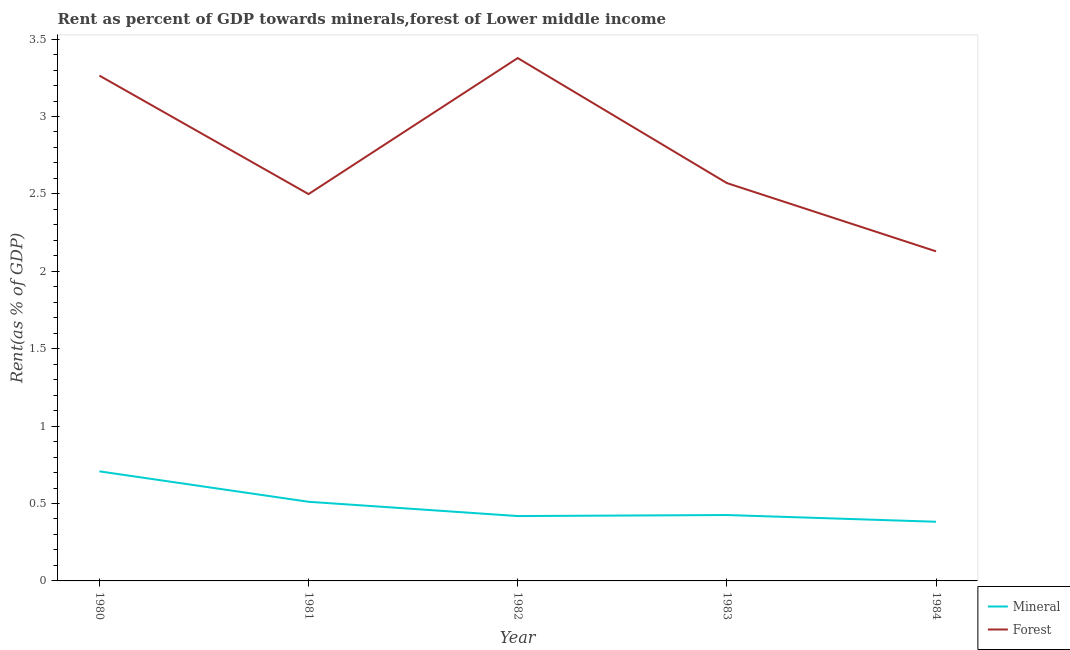Does the line corresponding to forest rent intersect with the line corresponding to mineral rent?
Your response must be concise. No. Is the number of lines equal to the number of legend labels?
Offer a very short reply. Yes. What is the forest rent in 1980?
Provide a short and direct response. 3.26. Across all years, what is the maximum forest rent?
Your answer should be compact. 3.38. Across all years, what is the minimum forest rent?
Your answer should be compact. 2.13. In which year was the mineral rent maximum?
Your answer should be compact. 1980. What is the total mineral rent in the graph?
Ensure brevity in your answer.  2.45. What is the difference between the forest rent in 1982 and that in 1984?
Make the answer very short. 1.25. What is the difference between the forest rent in 1983 and the mineral rent in 1982?
Ensure brevity in your answer.  2.15. What is the average mineral rent per year?
Provide a succinct answer. 0.49. In the year 1982, what is the difference between the mineral rent and forest rent?
Give a very brief answer. -2.96. In how many years, is the mineral rent greater than 2.2 %?
Offer a very short reply. 0. What is the ratio of the mineral rent in 1980 to that in 1982?
Your response must be concise. 1.69. Is the difference between the mineral rent in 1983 and 1984 greater than the difference between the forest rent in 1983 and 1984?
Ensure brevity in your answer.  No. What is the difference between the highest and the second highest forest rent?
Offer a very short reply. 0.11. What is the difference between the highest and the lowest mineral rent?
Your answer should be very brief. 0.33. In how many years, is the forest rent greater than the average forest rent taken over all years?
Offer a terse response. 2. Is the sum of the mineral rent in 1982 and 1984 greater than the maximum forest rent across all years?
Keep it short and to the point. No. Does the mineral rent monotonically increase over the years?
Your answer should be compact. No. Does the graph contain any zero values?
Your response must be concise. No. What is the title of the graph?
Your answer should be very brief. Rent as percent of GDP towards minerals,forest of Lower middle income. Does "From human activities" appear as one of the legend labels in the graph?
Offer a terse response. No. What is the label or title of the Y-axis?
Give a very brief answer. Rent(as % of GDP). What is the Rent(as % of GDP) in Mineral in 1980?
Give a very brief answer. 0.71. What is the Rent(as % of GDP) of Forest in 1980?
Your response must be concise. 3.26. What is the Rent(as % of GDP) of Mineral in 1981?
Give a very brief answer. 0.51. What is the Rent(as % of GDP) of Forest in 1981?
Offer a very short reply. 2.5. What is the Rent(as % of GDP) in Mineral in 1982?
Offer a terse response. 0.42. What is the Rent(as % of GDP) in Forest in 1982?
Keep it short and to the point. 3.38. What is the Rent(as % of GDP) of Mineral in 1983?
Make the answer very short. 0.43. What is the Rent(as % of GDP) of Forest in 1983?
Your answer should be compact. 2.57. What is the Rent(as % of GDP) of Mineral in 1984?
Your answer should be very brief. 0.38. What is the Rent(as % of GDP) in Forest in 1984?
Give a very brief answer. 2.13. Across all years, what is the maximum Rent(as % of GDP) in Mineral?
Give a very brief answer. 0.71. Across all years, what is the maximum Rent(as % of GDP) in Forest?
Ensure brevity in your answer.  3.38. Across all years, what is the minimum Rent(as % of GDP) in Mineral?
Ensure brevity in your answer.  0.38. Across all years, what is the minimum Rent(as % of GDP) in Forest?
Offer a very short reply. 2.13. What is the total Rent(as % of GDP) of Mineral in the graph?
Offer a terse response. 2.45. What is the total Rent(as % of GDP) of Forest in the graph?
Provide a succinct answer. 13.84. What is the difference between the Rent(as % of GDP) in Mineral in 1980 and that in 1981?
Keep it short and to the point. 0.2. What is the difference between the Rent(as % of GDP) of Forest in 1980 and that in 1981?
Provide a short and direct response. 0.77. What is the difference between the Rent(as % of GDP) of Mineral in 1980 and that in 1982?
Keep it short and to the point. 0.29. What is the difference between the Rent(as % of GDP) of Forest in 1980 and that in 1982?
Your answer should be very brief. -0.11. What is the difference between the Rent(as % of GDP) in Mineral in 1980 and that in 1983?
Give a very brief answer. 0.28. What is the difference between the Rent(as % of GDP) in Forest in 1980 and that in 1983?
Offer a terse response. 0.69. What is the difference between the Rent(as % of GDP) of Mineral in 1980 and that in 1984?
Your answer should be very brief. 0.33. What is the difference between the Rent(as % of GDP) in Forest in 1980 and that in 1984?
Offer a terse response. 1.14. What is the difference between the Rent(as % of GDP) of Mineral in 1981 and that in 1982?
Give a very brief answer. 0.09. What is the difference between the Rent(as % of GDP) in Forest in 1981 and that in 1982?
Your answer should be very brief. -0.88. What is the difference between the Rent(as % of GDP) in Mineral in 1981 and that in 1983?
Offer a terse response. 0.09. What is the difference between the Rent(as % of GDP) of Forest in 1981 and that in 1983?
Offer a very short reply. -0.07. What is the difference between the Rent(as % of GDP) in Mineral in 1981 and that in 1984?
Provide a short and direct response. 0.13. What is the difference between the Rent(as % of GDP) in Forest in 1981 and that in 1984?
Your answer should be compact. 0.37. What is the difference between the Rent(as % of GDP) in Mineral in 1982 and that in 1983?
Provide a succinct answer. -0.01. What is the difference between the Rent(as % of GDP) in Forest in 1982 and that in 1983?
Offer a very short reply. 0.81. What is the difference between the Rent(as % of GDP) in Mineral in 1982 and that in 1984?
Offer a very short reply. 0.04. What is the difference between the Rent(as % of GDP) of Forest in 1982 and that in 1984?
Make the answer very short. 1.25. What is the difference between the Rent(as % of GDP) of Mineral in 1983 and that in 1984?
Ensure brevity in your answer.  0.04. What is the difference between the Rent(as % of GDP) in Forest in 1983 and that in 1984?
Your answer should be very brief. 0.44. What is the difference between the Rent(as % of GDP) of Mineral in 1980 and the Rent(as % of GDP) of Forest in 1981?
Provide a short and direct response. -1.79. What is the difference between the Rent(as % of GDP) in Mineral in 1980 and the Rent(as % of GDP) in Forest in 1982?
Your answer should be very brief. -2.67. What is the difference between the Rent(as % of GDP) of Mineral in 1980 and the Rent(as % of GDP) of Forest in 1983?
Your response must be concise. -1.86. What is the difference between the Rent(as % of GDP) of Mineral in 1980 and the Rent(as % of GDP) of Forest in 1984?
Make the answer very short. -1.42. What is the difference between the Rent(as % of GDP) in Mineral in 1981 and the Rent(as % of GDP) in Forest in 1982?
Offer a terse response. -2.87. What is the difference between the Rent(as % of GDP) in Mineral in 1981 and the Rent(as % of GDP) in Forest in 1983?
Make the answer very short. -2.06. What is the difference between the Rent(as % of GDP) of Mineral in 1981 and the Rent(as % of GDP) of Forest in 1984?
Your answer should be compact. -1.62. What is the difference between the Rent(as % of GDP) in Mineral in 1982 and the Rent(as % of GDP) in Forest in 1983?
Provide a succinct answer. -2.15. What is the difference between the Rent(as % of GDP) in Mineral in 1982 and the Rent(as % of GDP) in Forest in 1984?
Your answer should be very brief. -1.71. What is the difference between the Rent(as % of GDP) of Mineral in 1983 and the Rent(as % of GDP) of Forest in 1984?
Your response must be concise. -1.7. What is the average Rent(as % of GDP) of Mineral per year?
Provide a succinct answer. 0.49. What is the average Rent(as % of GDP) in Forest per year?
Your answer should be very brief. 2.77. In the year 1980, what is the difference between the Rent(as % of GDP) in Mineral and Rent(as % of GDP) in Forest?
Your answer should be very brief. -2.56. In the year 1981, what is the difference between the Rent(as % of GDP) in Mineral and Rent(as % of GDP) in Forest?
Provide a succinct answer. -1.99. In the year 1982, what is the difference between the Rent(as % of GDP) in Mineral and Rent(as % of GDP) in Forest?
Provide a short and direct response. -2.96. In the year 1983, what is the difference between the Rent(as % of GDP) in Mineral and Rent(as % of GDP) in Forest?
Give a very brief answer. -2.14. In the year 1984, what is the difference between the Rent(as % of GDP) of Mineral and Rent(as % of GDP) of Forest?
Your answer should be compact. -1.75. What is the ratio of the Rent(as % of GDP) in Mineral in 1980 to that in 1981?
Ensure brevity in your answer.  1.38. What is the ratio of the Rent(as % of GDP) in Forest in 1980 to that in 1981?
Your answer should be compact. 1.31. What is the ratio of the Rent(as % of GDP) of Mineral in 1980 to that in 1982?
Make the answer very short. 1.69. What is the ratio of the Rent(as % of GDP) of Forest in 1980 to that in 1982?
Provide a short and direct response. 0.97. What is the ratio of the Rent(as % of GDP) in Mineral in 1980 to that in 1983?
Make the answer very short. 1.66. What is the ratio of the Rent(as % of GDP) in Forest in 1980 to that in 1983?
Your answer should be very brief. 1.27. What is the ratio of the Rent(as % of GDP) in Mineral in 1980 to that in 1984?
Make the answer very short. 1.85. What is the ratio of the Rent(as % of GDP) of Forest in 1980 to that in 1984?
Ensure brevity in your answer.  1.53. What is the ratio of the Rent(as % of GDP) in Mineral in 1981 to that in 1982?
Ensure brevity in your answer.  1.22. What is the ratio of the Rent(as % of GDP) of Forest in 1981 to that in 1982?
Ensure brevity in your answer.  0.74. What is the ratio of the Rent(as % of GDP) in Mineral in 1981 to that in 1983?
Your answer should be compact. 1.2. What is the ratio of the Rent(as % of GDP) in Forest in 1981 to that in 1983?
Provide a succinct answer. 0.97. What is the ratio of the Rent(as % of GDP) of Mineral in 1981 to that in 1984?
Make the answer very short. 1.34. What is the ratio of the Rent(as % of GDP) in Forest in 1981 to that in 1984?
Make the answer very short. 1.17. What is the ratio of the Rent(as % of GDP) in Mineral in 1982 to that in 1983?
Offer a very short reply. 0.98. What is the ratio of the Rent(as % of GDP) of Forest in 1982 to that in 1983?
Provide a short and direct response. 1.31. What is the ratio of the Rent(as % of GDP) in Mineral in 1982 to that in 1984?
Your response must be concise. 1.1. What is the ratio of the Rent(as % of GDP) of Forest in 1982 to that in 1984?
Provide a succinct answer. 1.59. What is the ratio of the Rent(as % of GDP) in Mineral in 1983 to that in 1984?
Make the answer very short. 1.11. What is the ratio of the Rent(as % of GDP) of Forest in 1983 to that in 1984?
Keep it short and to the point. 1.21. What is the difference between the highest and the second highest Rent(as % of GDP) of Mineral?
Provide a short and direct response. 0.2. What is the difference between the highest and the second highest Rent(as % of GDP) of Forest?
Offer a terse response. 0.11. What is the difference between the highest and the lowest Rent(as % of GDP) of Mineral?
Provide a succinct answer. 0.33. What is the difference between the highest and the lowest Rent(as % of GDP) in Forest?
Your answer should be very brief. 1.25. 